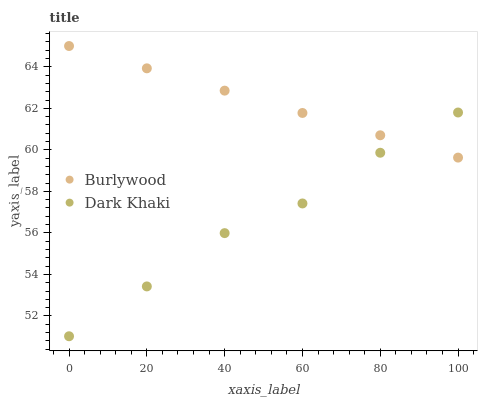Does Dark Khaki have the minimum area under the curve?
Answer yes or no. Yes. Does Burlywood have the maximum area under the curve?
Answer yes or no. Yes. Does Dark Khaki have the maximum area under the curve?
Answer yes or no. No. Is Burlywood the smoothest?
Answer yes or no. Yes. Is Dark Khaki the roughest?
Answer yes or no. Yes. Is Dark Khaki the smoothest?
Answer yes or no. No. Does Dark Khaki have the lowest value?
Answer yes or no. Yes. Does Burlywood have the highest value?
Answer yes or no. Yes. Does Dark Khaki have the highest value?
Answer yes or no. No. Does Dark Khaki intersect Burlywood?
Answer yes or no. Yes. Is Dark Khaki less than Burlywood?
Answer yes or no. No. Is Dark Khaki greater than Burlywood?
Answer yes or no. No. 